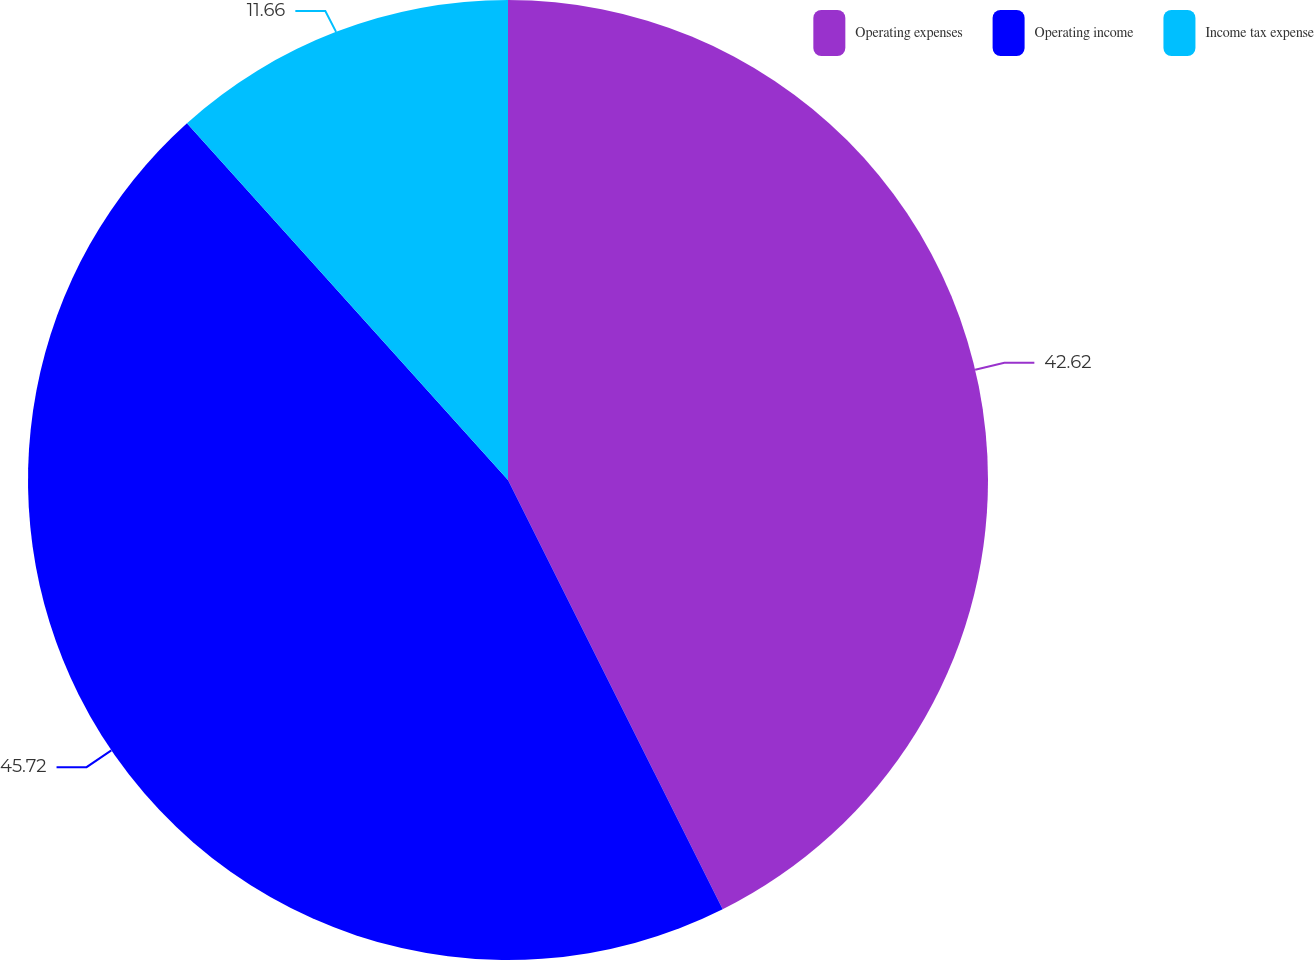<chart> <loc_0><loc_0><loc_500><loc_500><pie_chart><fcel>Operating expenses<fcel>Operating income<fcel>Income tax expense<nl><fcel>42.62%<fcel>45.72%<fcel>11.66%<nl></chart> 